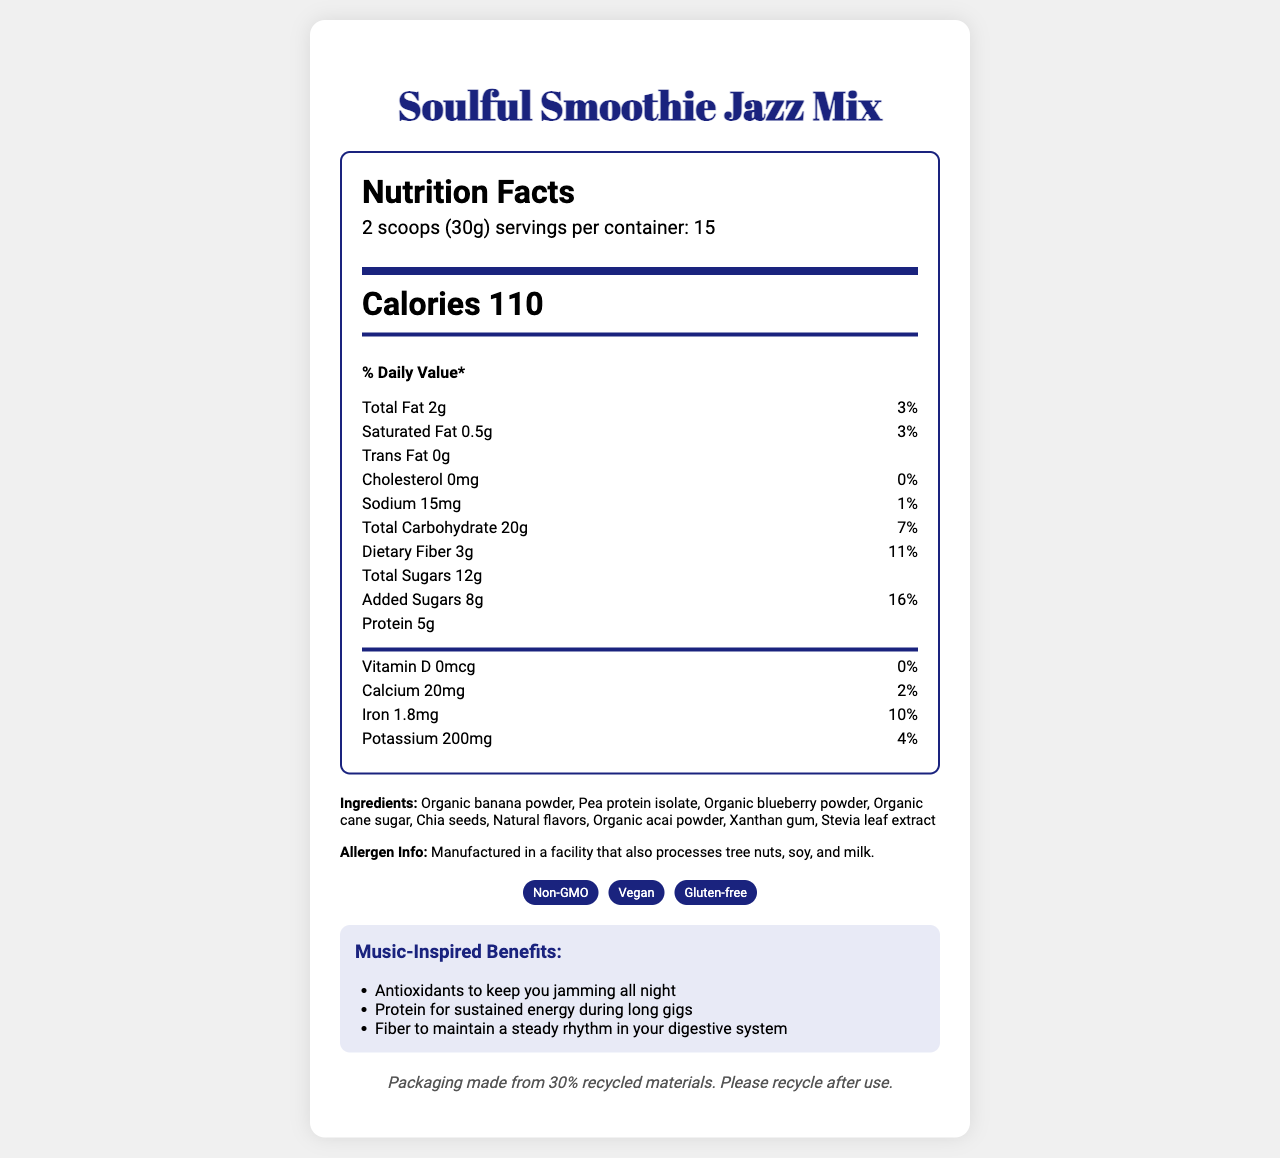How many calories are in a serving of Soulful Smoothie Jazz Mix? According to the Nutrition Facts section, each serving size of the Soulful Smoothie Jazz Mix contains 110 calories.
Answer: 110 What is the serving size for the Soulful Smoothie Jazz Mix? The serving size information is stated in the Nutrition Facts section as "2 scoops (30g)".
Answer: 2 scoops (30g) How many servings per container are there? The number of servings per container is listed under the Nutrition Facts section where it states "servings per container: 15".
Answer: 15 What are the two main benefits of drinking this smoothie according to the Music-Inspired Benefits? The Music-Inspired Benefits section lists several benefits, including antioxidants and protein for specific energy and health benefits.
Answer: Antioxidants to keep you jamming all night and Protein for sustained energy during long gigs Name three ingredients found in the Soulful Smoothie Jazz Mix. The ingredients list includes various items such as organic banana powder, pea protein isolate, and organic blueberry powder.
Answer: Organic banana powder, Pea protein isolate, Organic blueberry powder How much dietary fiber is in each serving, and what percentage of the daily value does it represent? The Nutrition Facts section shows that each serving contains 3 grams of dietary fiber, which represents 11% of the daily value.
Answer: 3g, 11% Which of the following is a unique feature of the Soulful Smoothie Jazz Mix packaging? A. Saxophone-shaped tin B. Recyclable plastic container C. Glass bottle The packaging description mentions that it comes in a "Recyclable saxophone-shaped tin with embossed musical notes".
Answer: A. Saxophone-shaped tin What is the recommended preparation method for the Soulful Smoothie Jazz Mix? The preparation instructions specifically state to mix 2 scoops with 8 oz of cold water or plant-based milk, shake well, and enjoy.
Answer: Mix 2 scoops with 8 oz of cold water or plant-based milk. Shake well and enjoy the smooth, jazzy flavors. Does the Soulful Smoothie Jazz Mix contain any cholesterol? The Nutrition Facts section shows that it contains 0mg of cholesterol, which is 0% of the daily value.
Answer: No What are some of the special features of the Soulful Smoothie Jazz Mix? The special features section lists that the product is Non-GMO, Vegan, and Gluten-free.
Answer: Non-GMO, Vegan, Gluten-free Summarize the main idea of the entire document. The document includes information about the nutrition content and health benefits inspired by music, emphasizing the product's unique saxophone-shaped packaging and its environmentally friendly aspects.
Answer: The document provides the Nutrition Facts, ingredients, special features, packaging description, preparation instructions, and benefits of the Soulful Smoothie Jazz Mix. It highlights the product's nutrition and health benefits, its unique saxophone-themed packaging, and its suitability for various diets (Non-GMO, Vegan, and Gluten-free). How much calcium does each serving provide? The Nutrition Facts section lists calcium content as 20mg per serving.
Answer: 20mg Which of these is an ingredient in the Soulful Smoothie Jazz Mix? A. Whey protein B. Pea protein isolate C. Soy protein According to the ingredients list, Pea protein isolate is one of the ingredients, not whey or soy protein.
Answer: B. Pea protein isolate How many grams of added sugars are in each serving? The Nutrition Facts section specifies that there are 8 grams of added sugars per serving.
Answer: 8g What is the percentage daily value of potassium in a serving? The Nutrition Facts section states that potassium represents 4% of the daily value per serving.
Answer: 4% What flavor-enhancing natural extract is included in the ingredients? The Ingredients list includes Stevia leaf extract as one of the flavor-enhancing components.
Answer: Stevia leaf extract How much total fat does one serving contain, and what is its percentage daily value? The Nutrition Facts show that a serving contains 2 grams of total fat, which is 3% of the daily value.
Answer: 2g, 3% How is the Soulful Smoothie Jazz Mix beneficial for your digestive system? The Music-Inspired Benefits section mentions that the fiber content helps maintain a steady rhythm in the digestive system.
Answer: Fiber to maintain a steady rhythm in your digestive system Is this product suitable for someone avoiding gluten? The document mentions that the Soulful Smoothie Jazz Mix is gluten-free in the special features section.
Answer: Yes What is the exact composition of the Sustainable Note? Although the document states the percentage of recycled materials (30%) in the sustainability note, it does not provide exact composition details.
Answer: Cannot be determined 